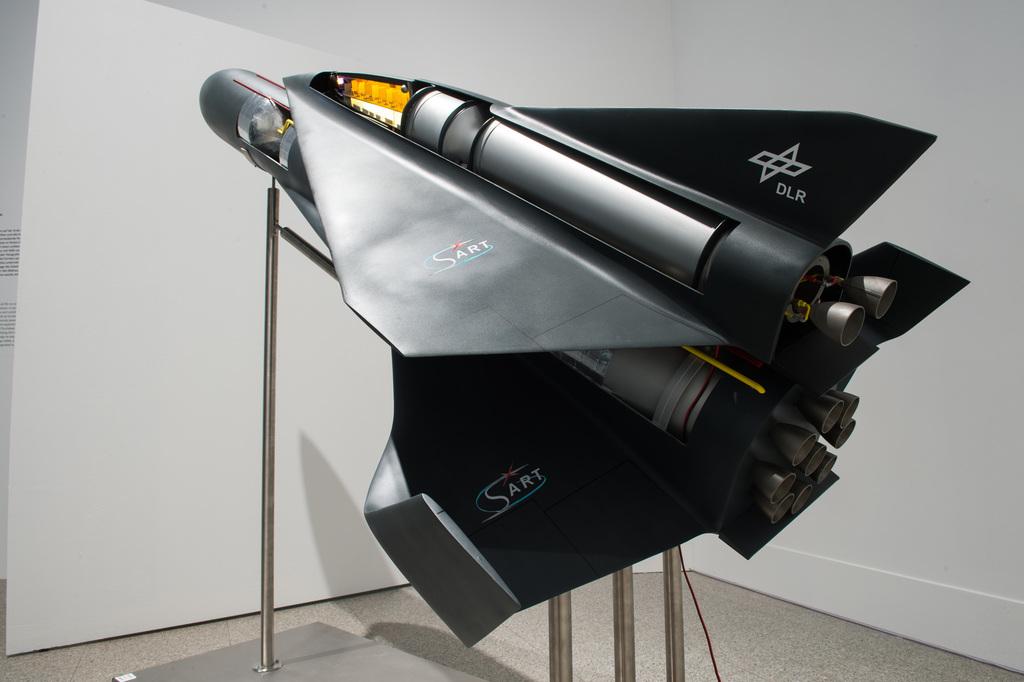What name is written twice on the wings?
Make the answer very short. Sart. 